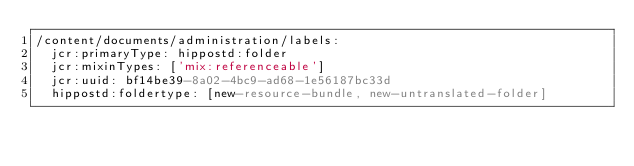Convert code to text. <code><loc_0><loc_0><loc_500><loc_500><_YAML_>/content/documents/administration/labels:
  jcr:primaryType: hippostd:folder
  jcr:mixinTypes: ['mix:referenceable']
  jcr:uuid: bf14be39-8a02-4bc9-ad68-1e56187bc33d
  hippostd:foldertype: [new-resource-bundle, new-untranslated-folder]
</code> 